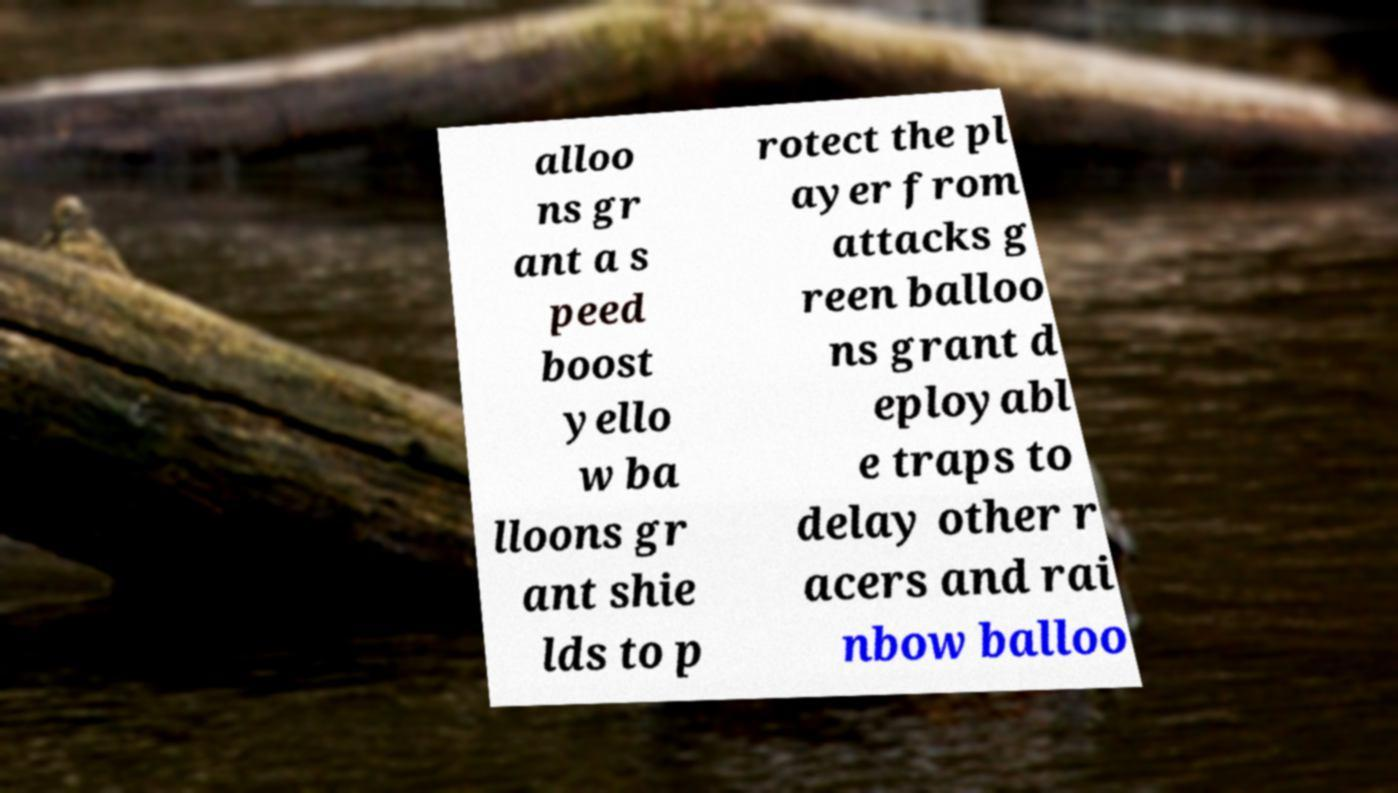There's text embedded in this image that I need extracted. Can you transcribe it verbatim? alloo ns gr ant a s peed boost yello w ba lloons gr ant shie lds to p rotect the pl ayer from attacks g reen balloo ns grant d eployabl e traps to delay other r acers and rai nbow balloo 